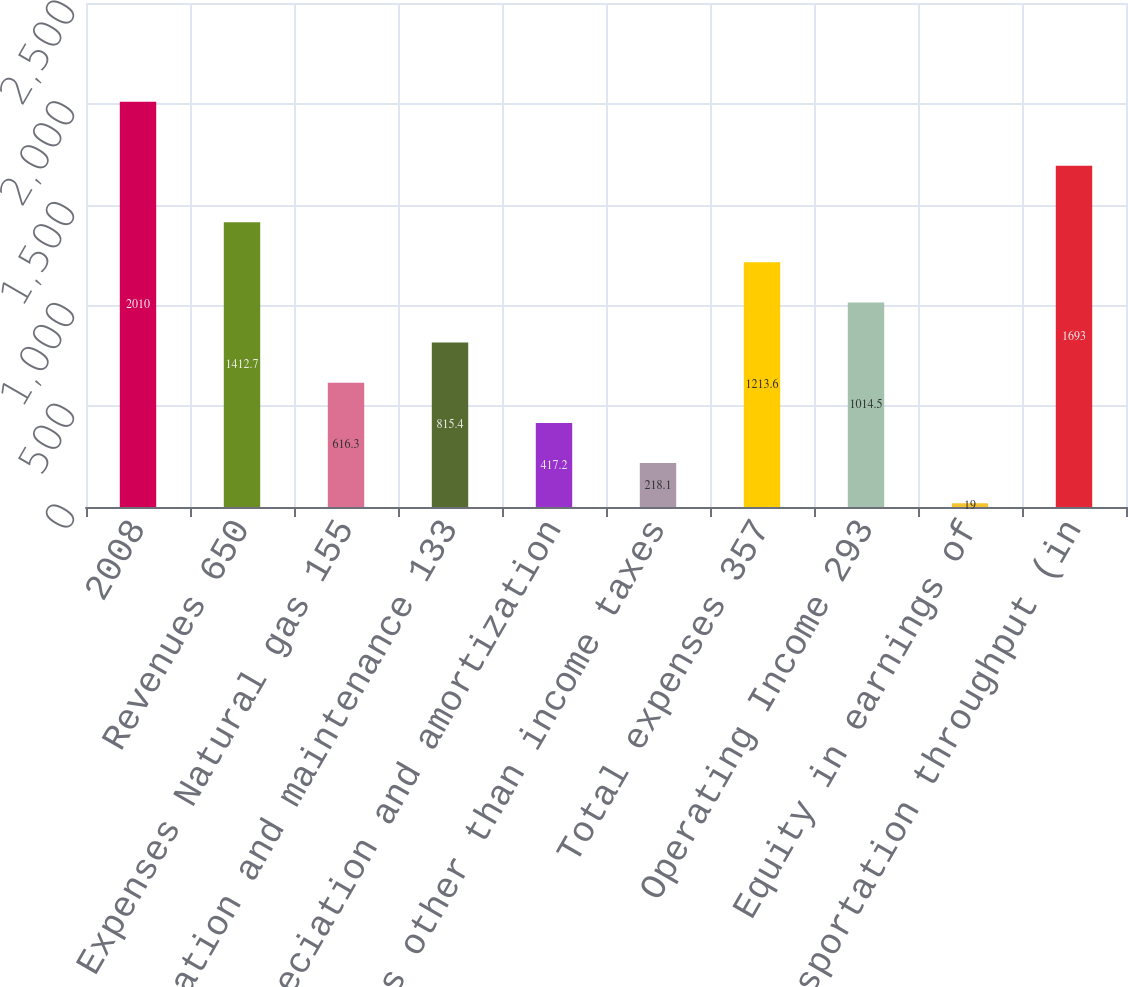Convert chart to OTSL. <chart><loc_0><loc_0><loc_500><loc_500><bar_chart><fcel>2008<fcel>Revenues 650<fcel>Expenses Natural gas 155<fcel>Operation and maintenance 133<fcel>Depreciation and amortization<fcel>Taxes other than income taxes<fcel>Total expenses 357<fcel>Operating Income 293<fcel>Equity in earnings of<fcel>Transportation throughput (in<nl><fcel>2010<fcel>1412.7<fcel>616.3<fcel>815.4<fcel>417.2<fcel>218.1<fcel>1213.6<fcel>1014.5<fcel>19<fcel>1693<nl></chart> 